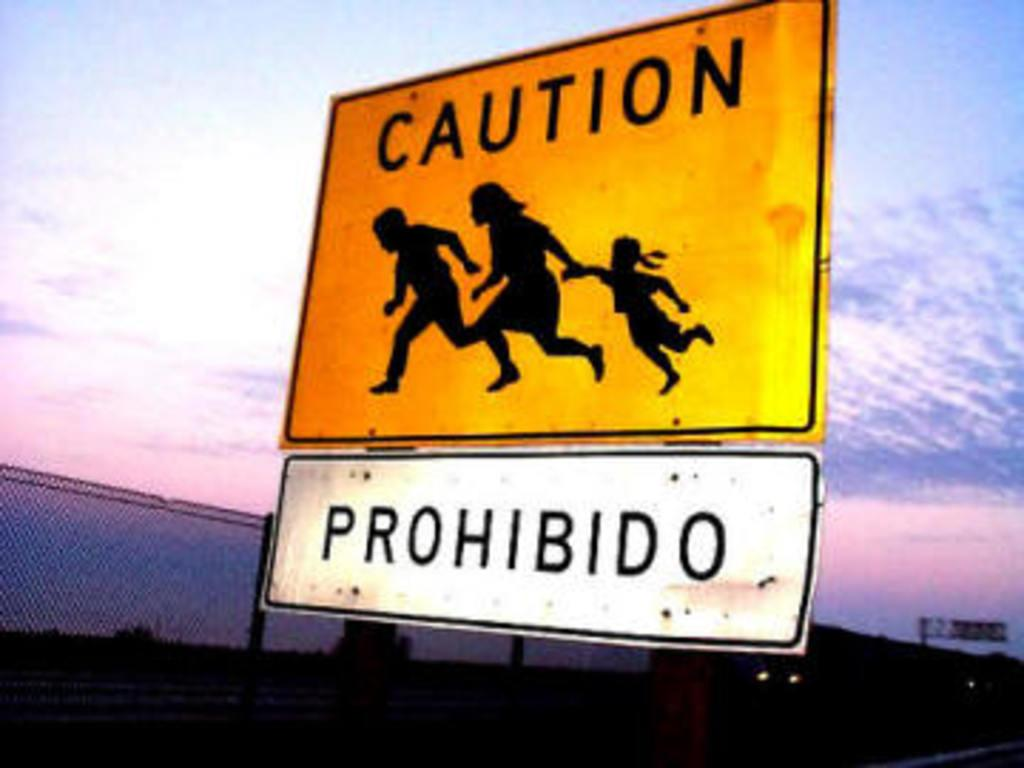<image>
Write a terse but informative summary of the picture. A caution sign with the silhouette of a man , woman, and child, running says prohibited in another language underneath it. 